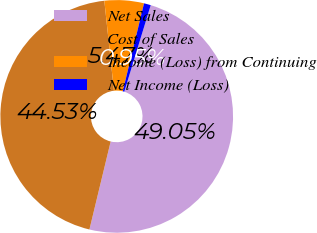<chart> <loc_0><loc_0><loc_500><loc_500><pie_chart><fcel>Net Sales<fcel>Cost of Sales<fcel>Income (Loss) from Continuing<fcel>Net Income (Loss)<nl><fcel>49.05%<fcel>44.53%<fcel>5.47%<fcel>0.95%<nl></chart> 